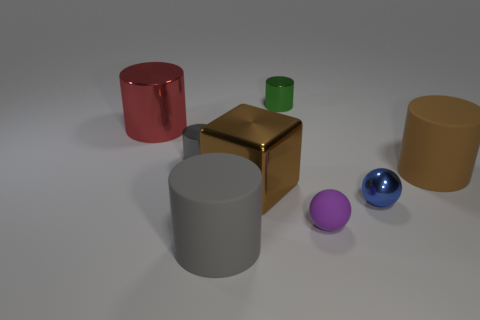There is a gray cylinder in front of the brown metallic block; how big is it?
Your answer should be very brief. Large. There is a cylinder that is the same color as the large cube; what size is it?
Give a very brief answer. Large. Is there a yellow block made of the same material as the blue ball?
Provide a succinct answer. No. Are the small gray object and the cube made of the same material?
Make the answer very short. Yes. There is another ball that is the same size as the blue shiny sphere; what is its color?
Your answer should be very brief. Purple. How many other objects are the same shape as the big red thing?
Provide a succinct answer. 4. There is a blue metal ball; is its size the same as the metallic cylinder that is on the right side of the large shiny block?
Make the answer very short. Yes. How many things are either large purple shiny balls or tiny purple spheres?
Provide a succinct answer. 1. What number of other things are there of the same size as the blue metal ball?
Give a very brief answer. 3. There is a big metallic cube; is it the same color as the matte cylinder that is right of the blue metallic ball?
Offer a very short reply. Yes. 